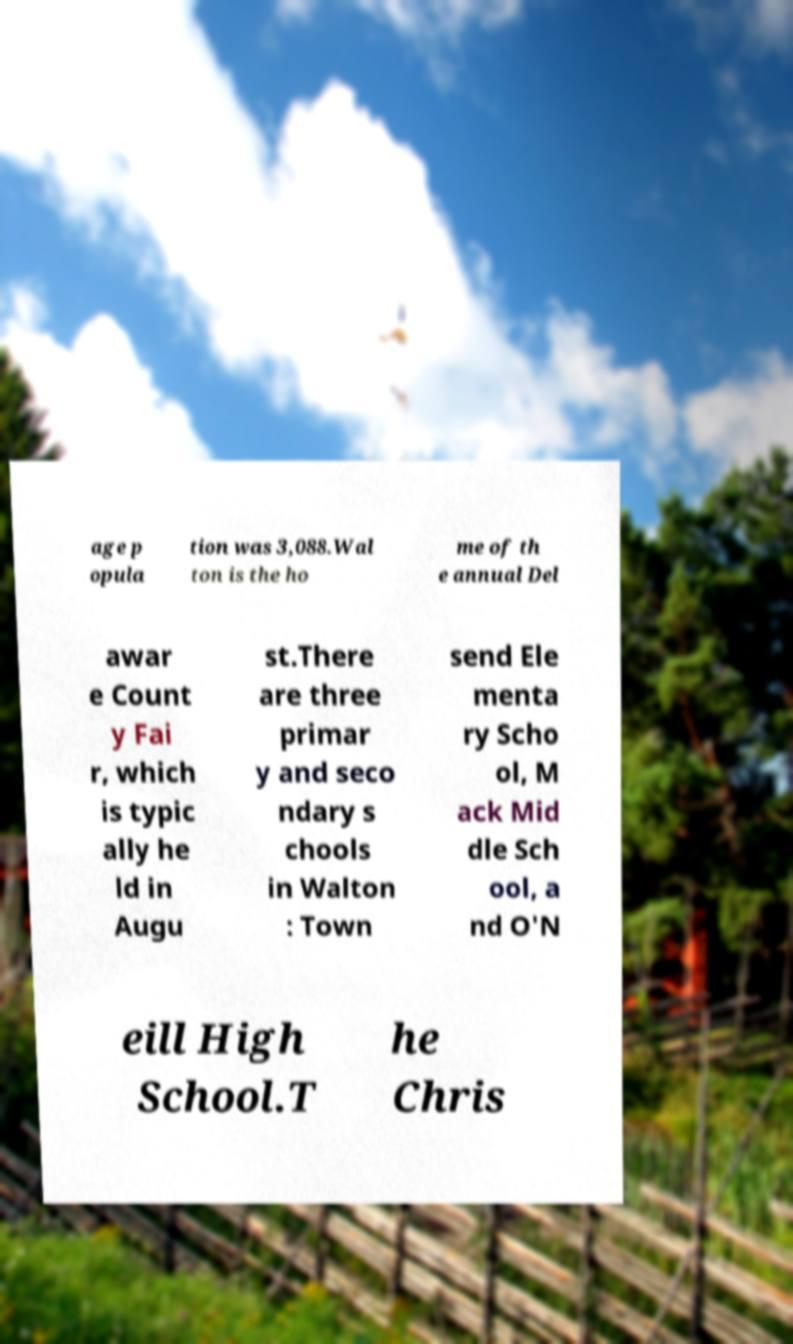There's text embedded in this image that I need extracted. Can you transcribe it verbatim? age p opula tion was 3,088.Wal ton is the ho me of th e annual Del awar e Count y Fai r, which is typic ally he ld in Augu st.There are three primar y and seco ndary s chools in Walton : Town send Ele menta ry Scho ol, M ack Mid dle Sch ool, a nd O'N eill High School.T he Chris 